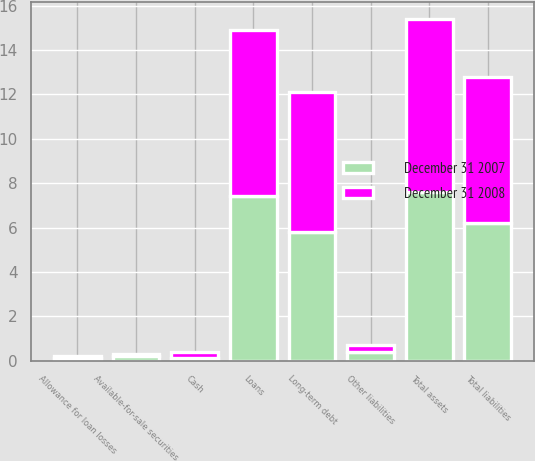Convert chart to OTSL. <chart><loc_0><loc_0><loc_500><loc_500><stacked_bar_chart><ecel><fcel>Cash<fcel>Available-for-sale securities<fcel>Loans<fcel>Allowance for loan losses<fcel>Total assets<fcel>Long-term debt<fcel>Other liabilities<fcel>Total liabilities<nl><fcel>December 31 2008<fcel>0.3<fcel>0.1<fcel>7.5<fcel>0.1<fcel>7.8<fcel>6.3<fcel>0.3<fcel>6.6<nl><fcel>December 31 2007<fcel>0.1<fcel>0.2<fcel>7.4<fcel>0.1<fcel>7.6<fcel>5.8<fcel>0.4<fcel>6.2<nl></chart> 